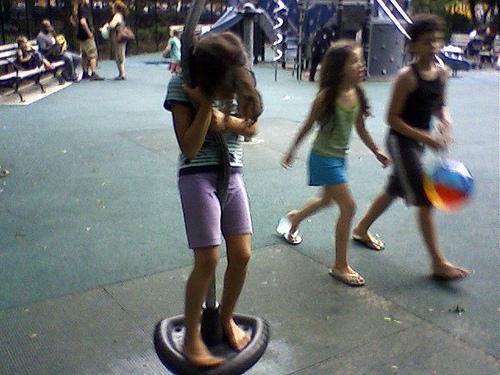How many people are sitting on the bench?
Give a very brief answer. 2. How many people are on the spinning toy?
Give a very brief answer. 1. 